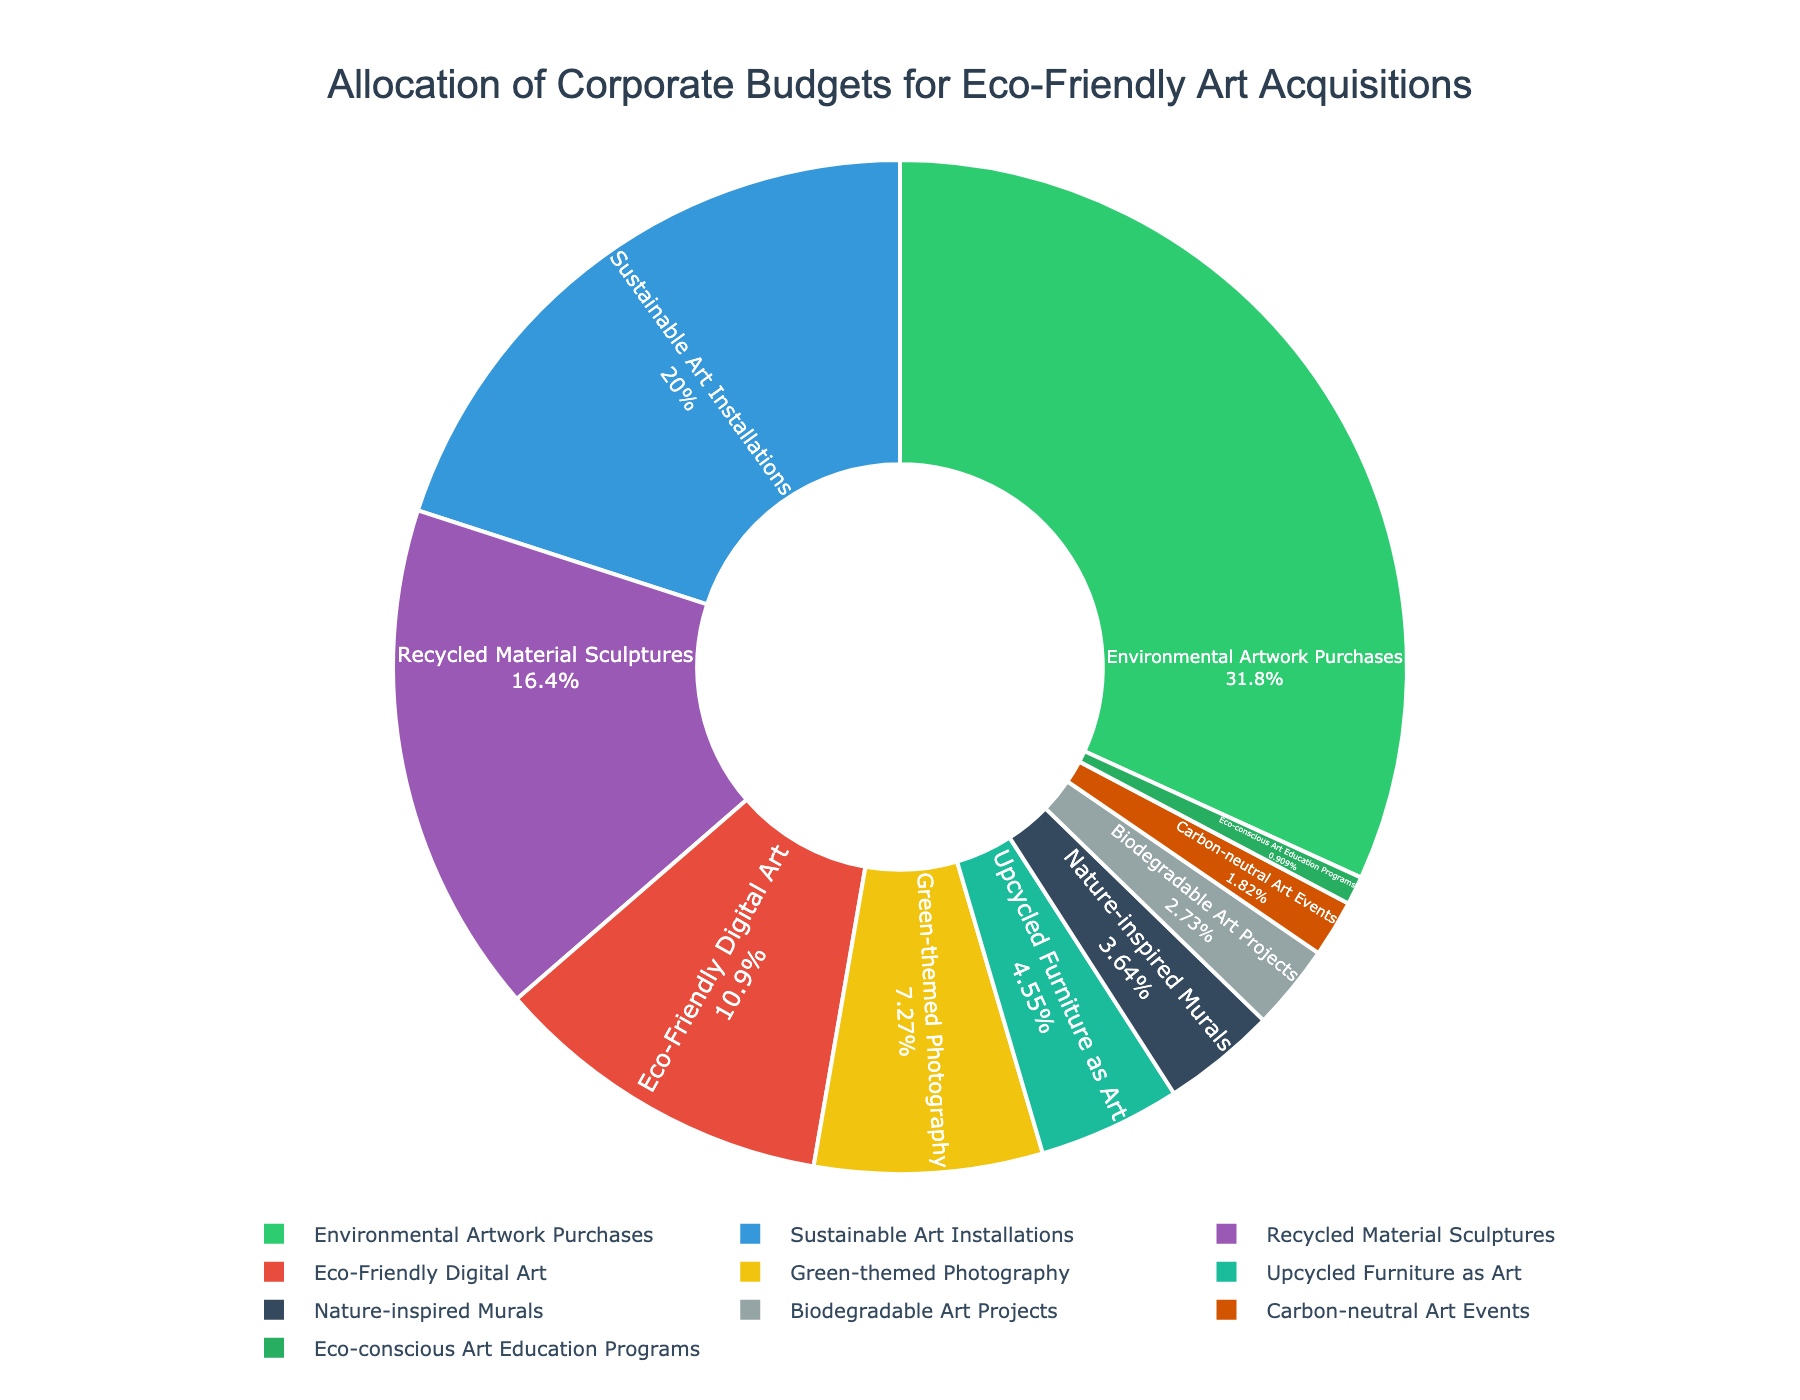What percentage of the budget is allocated to Environmental Artwork Purchases? The figure shows a section labeled as Environmental Artwork Purchases with a percentage value. Refer to the chart to locate the specific section and read its value.
Answer: 35% How much more budget is allocated to Sustainable Art Installations compared to Recycled Material Sculptures? First, find the percentages for Sustainable Art Installations (22%) and Recycled Material Sculptures (18%). Subtract the smaller percentage from the larger one: 22% - 18%.
Answer: 4% If Green-themed Photography and Upcycled Furniture as Art were combined into a single category, what percentage of the budget would it represent? Add the percentages of Green-themed Photography (8%) and Upcycled Furniture as Art (5%) to get the combined budget allocation: 8% + 5%.
Answer: 13% Which category gets the least amount of budget allocation, and what is its percentage? Identify the category with the smallest segment/section in the pie chart. The label and percentage next to the smallest slice represent this value.
Answer: Eco-conscious Art Education Programs, 1% Is the budget allocation for Sustainable Art Installations greater than the combined allocation for Biodegradable Art Projects, Carbon-neutral Art Events, and Eco-conscious Art Education Programs? First, sum the percentages for Biodegradable Art Projects (3%), Carbon-neutral Art Events (2%), and Eco-conscious Art Education Programs (1%). Then compare this total (3% + 2% + 1% = 6%) to the percentage for Sustainable Art Installations (22%).
Answer: Yes Rank the categories from highest to lowest budget allocation. List all categories and their percentages in descending order. Environmental Artwork Purchases: 35%, Sustainable Art Installations: 22%, Recycled Material Sculptures: 18%, Eco-Friendly Digital Art: 12%, Green-themed Photography: 8%, Upcycled Furniture as Art: 5%, Nature-inspired Murals: 4%, Biodegradable Art Projects: 3%, Carbon-neutral Art Events: 2%, Eco-conscious Art Education Programs: 1%.
Answer: Environmental Artwork Purchases, Sustainable Art Installations, Recycled Material Sculptures, Eco-Friendly Digital Art, Green-themed Photography, Upcycled Furniture as Art, Nature-inspired Murals, Biodegradable Art Projects, Carbon-neutral Art Events, Eco-conscious Art Education Programs What is the combined budget allocation for categories that fall under 5% individually? Look for all categories with individual percentages of less than 5% and sum these values: Upcycled Furniture as Art (5%), Nature-inspired Murals (4%), Biodegradable Art Projects (3%), Carbon-neutral Art Events (2%), Eco-conscious Art Education Programs (1%).
Answer: 15% Which two categories together form the largest portion of the pie chart? Identify the segments with the two highest individual percentages: Environmental Artwork Purchases (35%) and Sustainable Art Installations (22%). Combine their values: 35% + 22%.
Answer: Environmental Artwork Purchases and Sustainable Art Installations, 57% Do Nature-inspired Murals receive a higher budget allocation than Eco-Friendly Digital Art? Compare the individual percentages for Nature-inspired Murals (4%) and Eco-Friendly Digital Art (12%).
Answer: No By how much does the allocation for Recycled Material Sculptures exceed that of Green-themed Photography? Find the percentages for Recycled Material Sculptures (18%) and Green-themed Photography (8%), then subtract the smaller percentage from the larger one: 18% - 8%.
Answer: 10% 